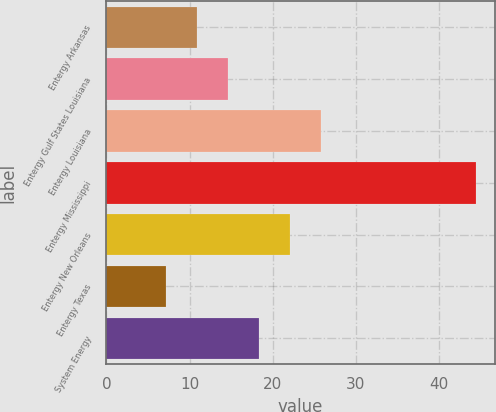Convert chart to OTSL. <chart><loc_0><loc_0><loc_500><loc_500><bar_chart><fcel>Entergy Arkansas<fcel>Entergy Gulf States Louisiana<fcel>Entergy Louisiana<fcel>Entergy Mississippi<fcel>Entergy New Orleans<fcel>Entergy Texas<fcel>System Energy<nl><fcel>10.93<fcel>14.66<fcel>25.85<fcel>44.5<fcel>22.12<fcel>7.2<fcel>18.39<nl></chart> 